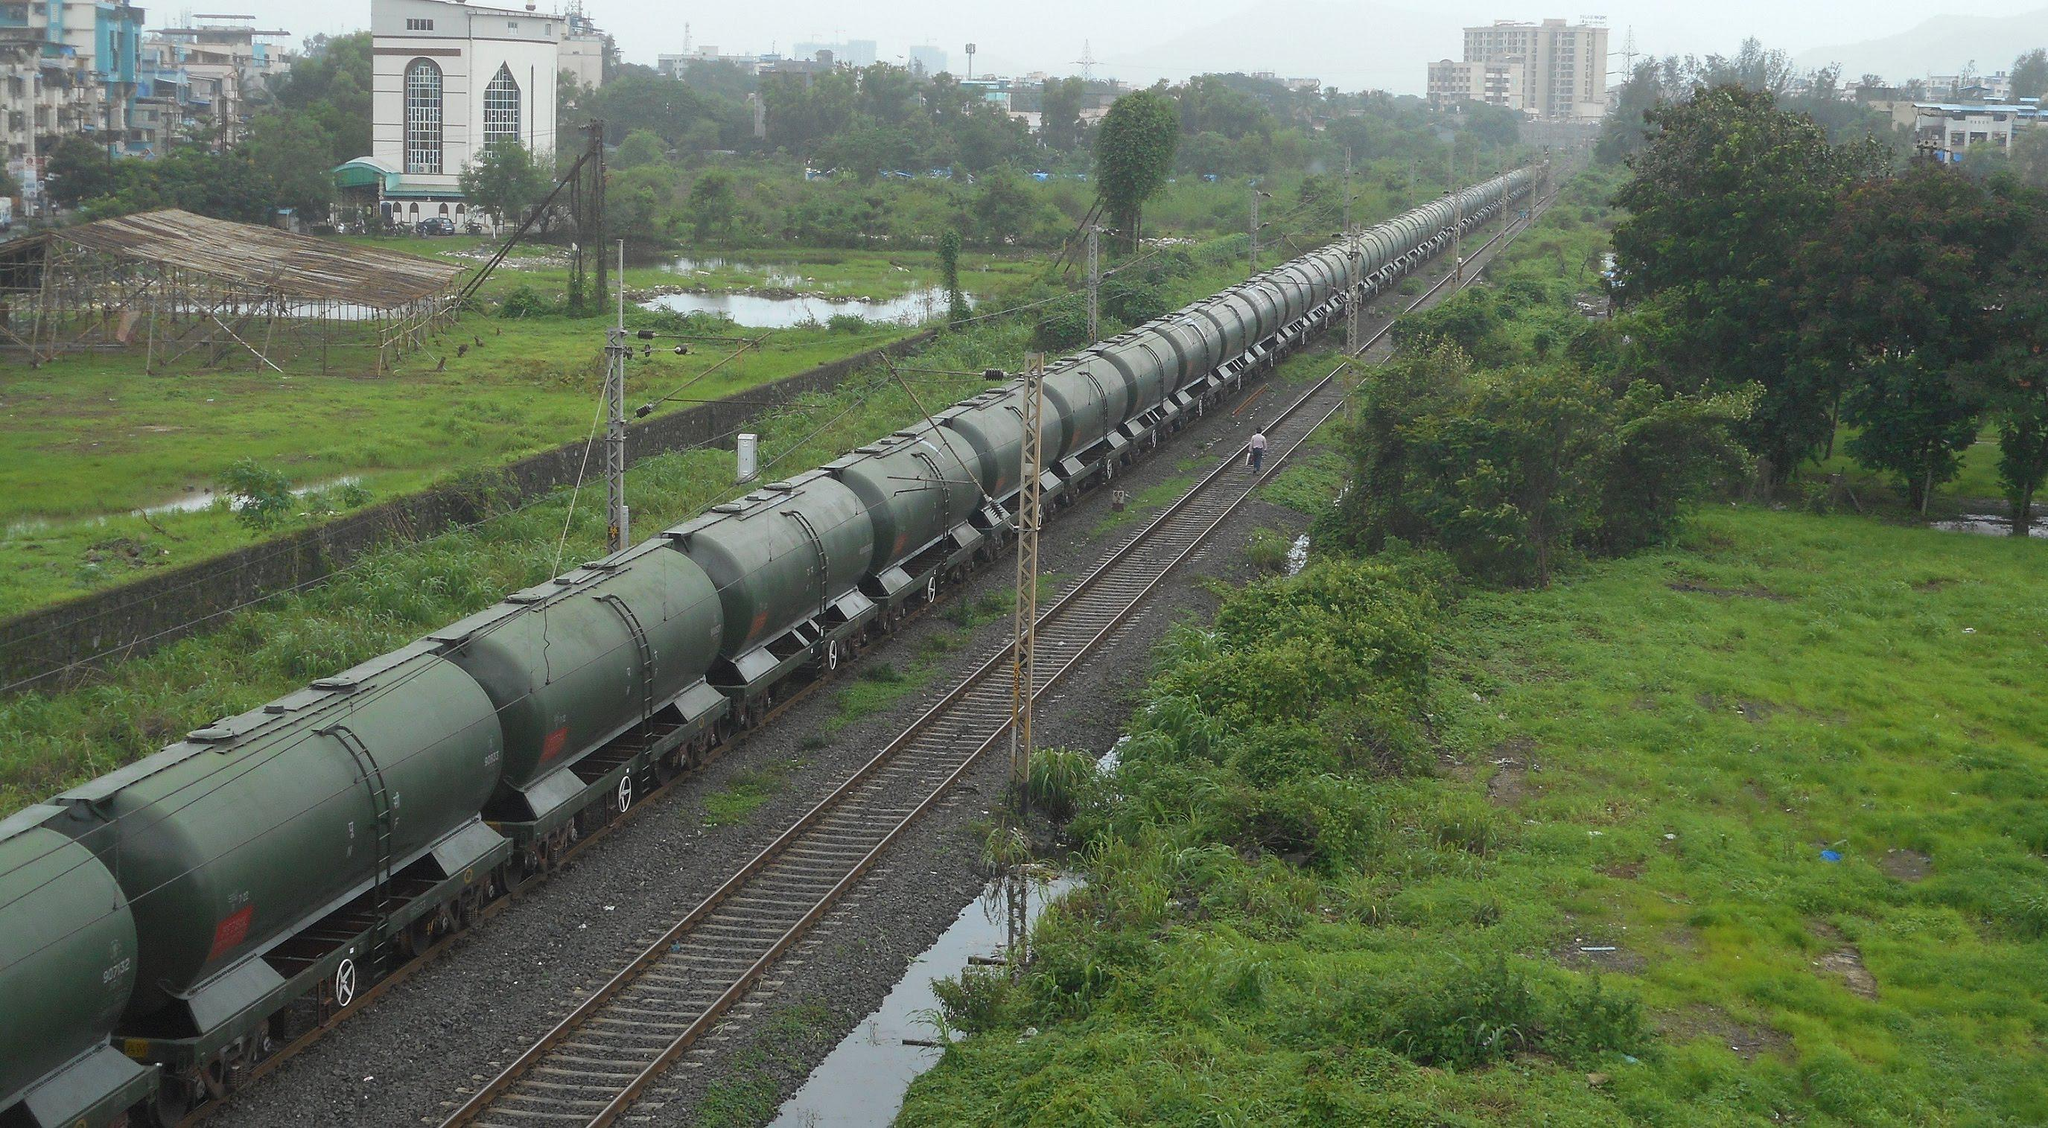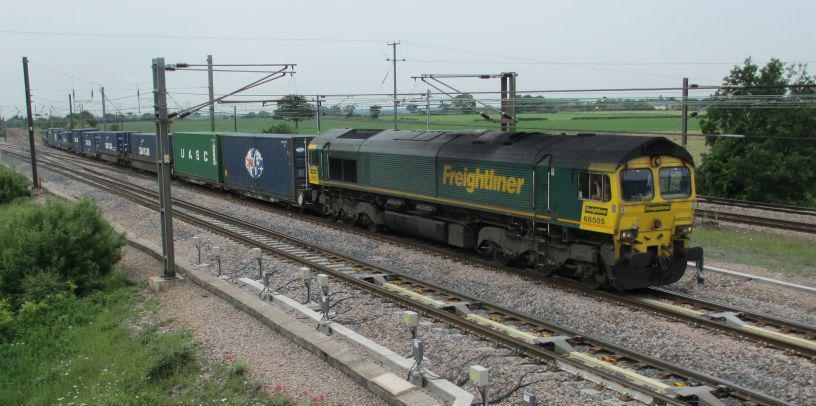The first image is the image on the left, the second image is the image on the right. Considering the images on both sides, is "Right image shows a green train moving in a rightward direction." valid? Answer yes or no. Yes. The first image is the image on the left, the second image is the image on the right. Analyze the images presented: Is the assertion "At least one of the trains in one of the images is passing through a grassy area." valid? Answer yes or no. Yes. 